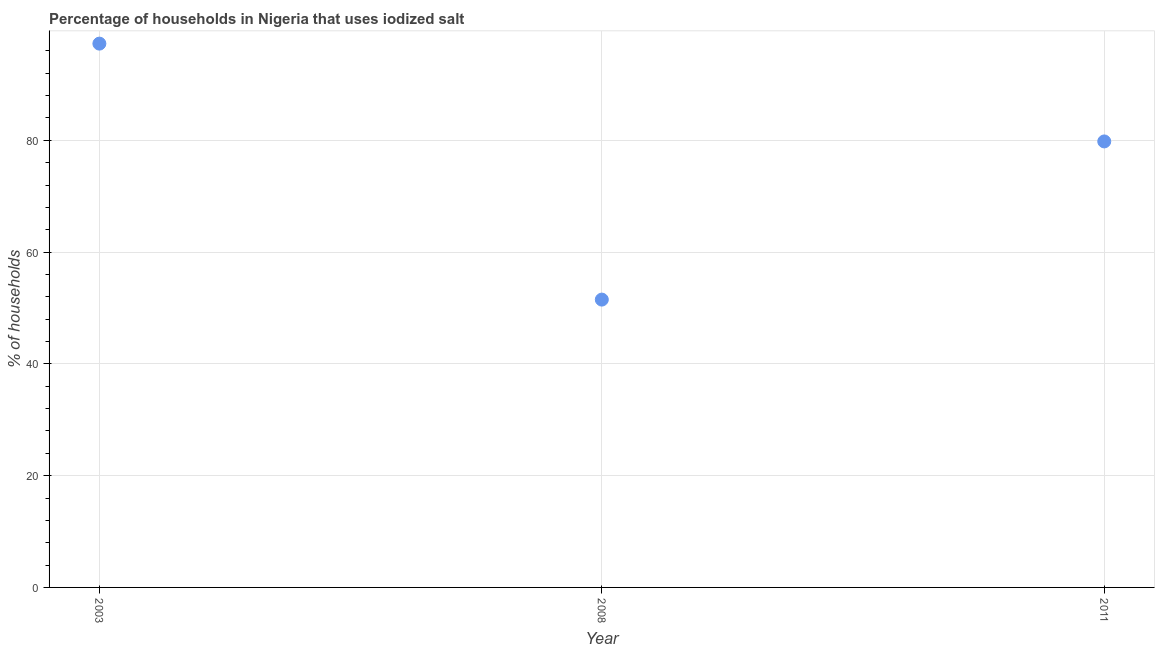What is the percentage of households where iodized salt is consumed in 2011?
Offer a very short reply. 79.8. Across all years, what is the maximum percentage of households where iodized salt is consumed?
Your answer should be very brief. 97.3. Across all years, what is the minimum percentage of households where iodized salt is consumed?
Make the answer very short. 51.5. In which year was the percentage of households where iodized salt is consumed maximum?
Your answer should be very brief. 2003. In which year was the percentage of households where iodized salt is consumed minimum?
Your answer should be very brief. 2008. What is the sum of the percentage of households where iodized salt is consumed?
Make the answer very short. 228.6. What is the difference between the percentage of households where iodized salt is consumed in 2003 and 2008?
Make the answer very short. 45.8. What is the average percentage of households where iodized salt is consumed per year?
Your answer should be very brief. 76.2. What is the median percentage of households where iodized salt is consumed?
Provide a short and direct response. 79.8. What is the ratio of the percentage of households where iodized salt is consumed in 2003 to that in 2008?
Ensure brevity in your answer.  1.89. Is the percentage of households where iodized salt is consumed in 2008 less than that in 2011?
Your answer should be compact. Yes. Is the difference between the percentage of households where iodized salt is consumed in 2008 and 2011 greater than the difference between any two years?
Provide a succinct answer. No. What is the difference between the highest and the lowest percentage of households where iodized salt is consumed?
Your answer should be compact. 45.8. Does the percentage of households where iodized salt is consumed monotonically increase over the years?
Make the answer very short. No. How many dotlines are there?
Offer a terse response. 1. Does the graph contain grids?
Keep it short and to the point. Yes. What is the title of the graph?
Provide a succinct answer. Percentage of households in Nigeria that uses iodized salt. What is the label or title of the Y-axis?
Keep it short and to the point. % of households. What is the % of households in 2003?
Offer a very short reply. 97.3. What is the % of households in 2008?
Your response must be concise. 51.5. What is the % of households in 2011?
Offer a terse response. 79.8. What is the difference between the % of households in 2003 and 2008?
Offer a terse response. 45.8. What is the difference between the % of households in 2008 and 2011?
Your answer should be compact. -28.3. What is the ratio of the % of households in 2003 to that in 2008?
Offer a terse response. 1.89. What is the ratio of the % of households in 2003 to that in 2011?
Offer a very short reply. 1.22. What is the ratio of the % of households in 2008 to that in 2011?
Your answer should be very brief. 0.65. 